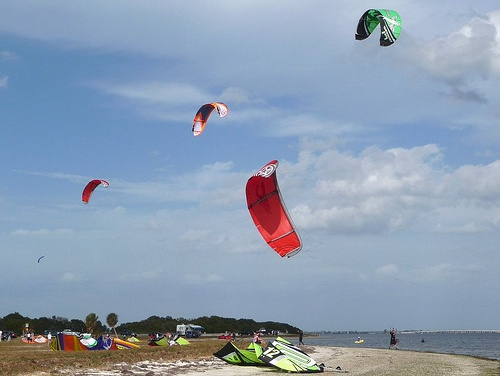Describe the objects in this image and their specific colors. I can see kite in darkgray, brown, maroon, and red tones, kite in darkgray, black, lightgreen, and lightgray tones, kite in darkgray, lavender, navy, and black tones, kite in darkgray, maroon, and brown tones, and people in darkgray, black, and gray tones in this image. 